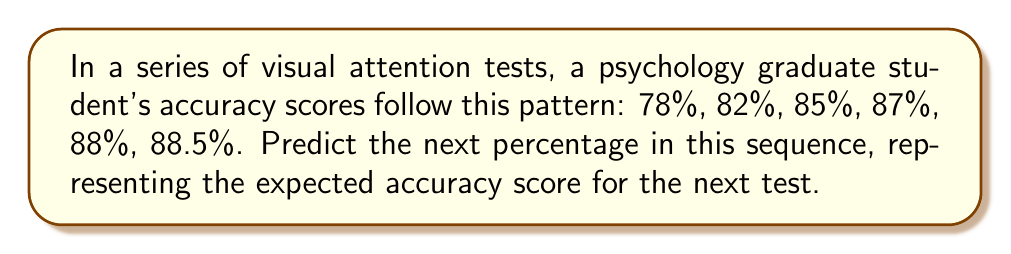Help me with this question. To predict the next number in this sequence, we need to analyze the pattern of changes between consecutive terms:

1. From 78% to 82%: Increase of 4%
2. From 82% to 85%: Increase of 3%
3. From 85% to 87%: Increase of 2%
4. From 87% to 88%: Increase of 1%
5. From 88% to 88.5%: Increase of 0.5%

We can observe that the increase is halving each time:

$$4 \rightarrow 3 \rightarrow 2 \rightarrow 1 \rightarrow 0.5$$

Following this pattern, the next increase should be half of 0.5, which is 0.25.

Therefore, the predicted next score would be:

$$88.5\% + 0.25\% = 88.75\%$$

This pattern is consistent with the concept of diminishing returns in learning and performance improvement, which is relevant to attention tests and cognitive psychology.
Answer: 88.75% 